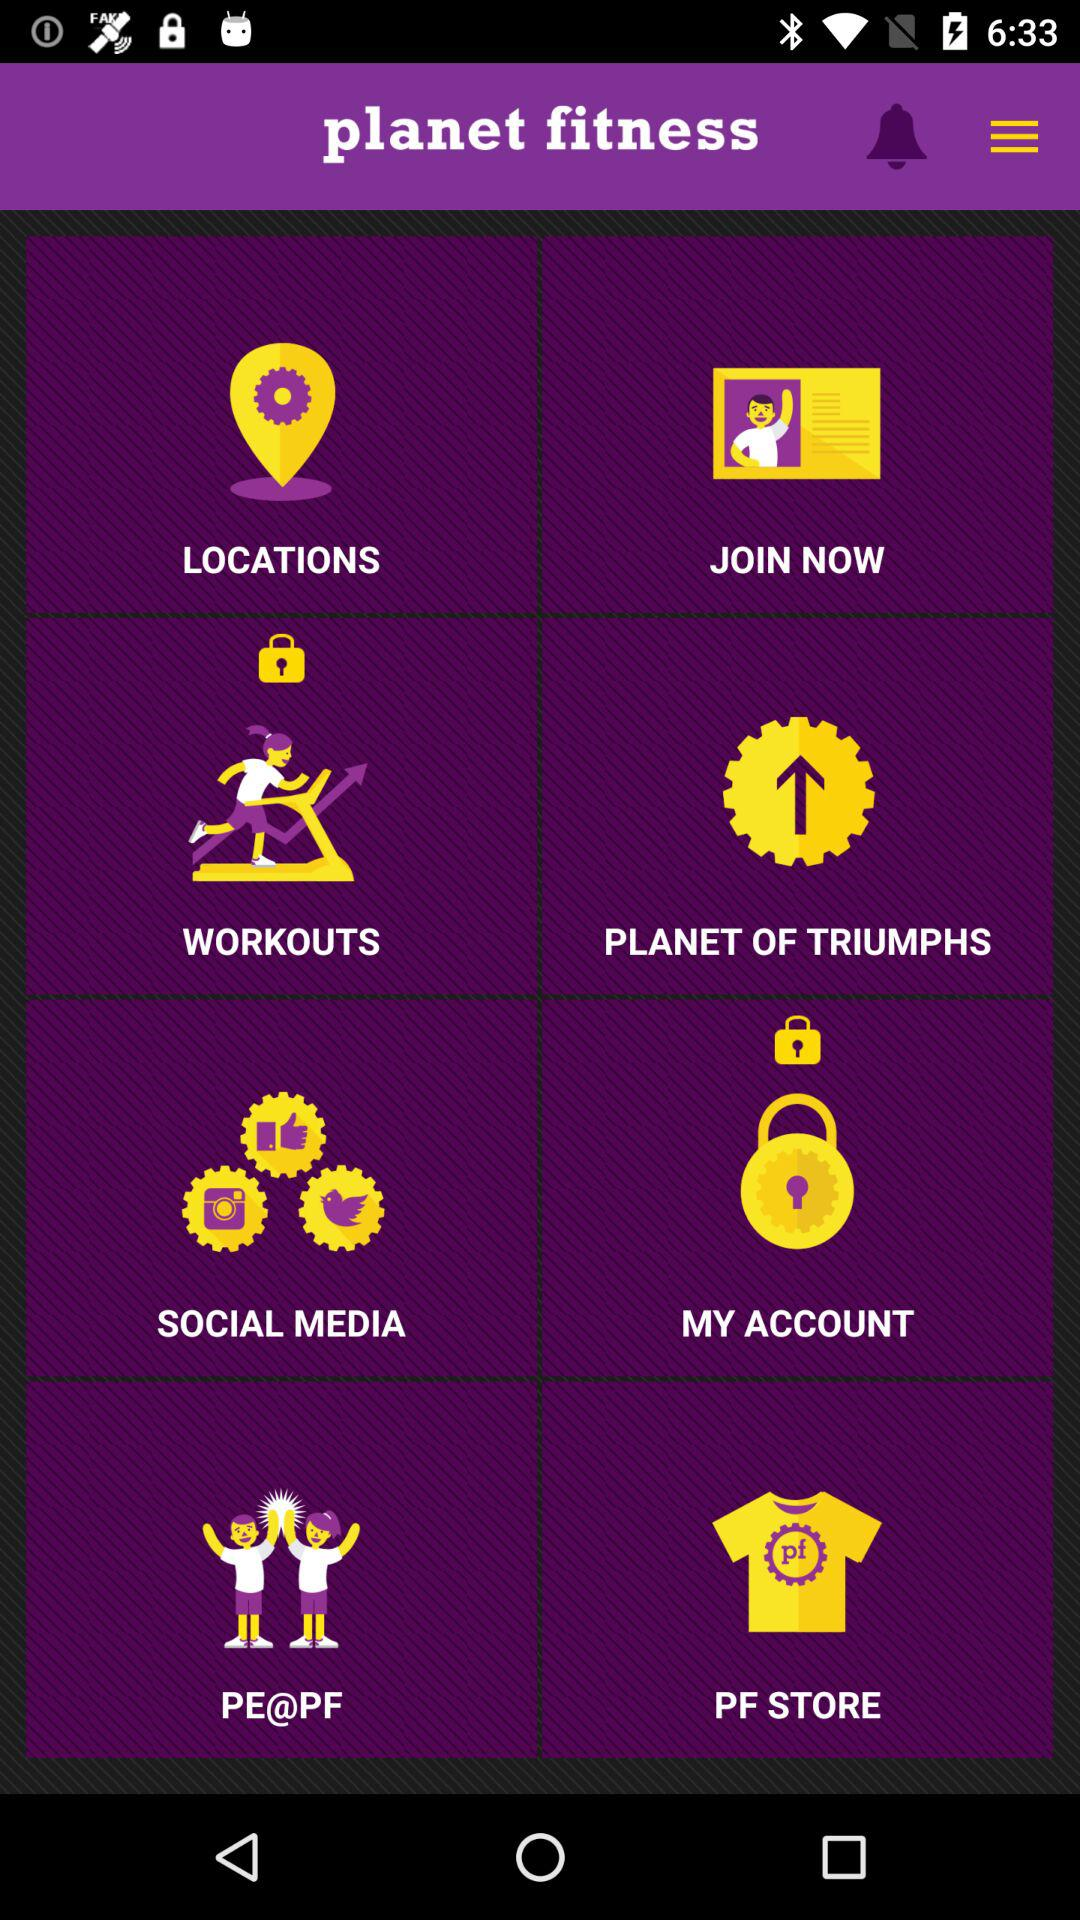Which options are locked? The locked options are "WORKOUTS" and "MY ACCOUNT". 